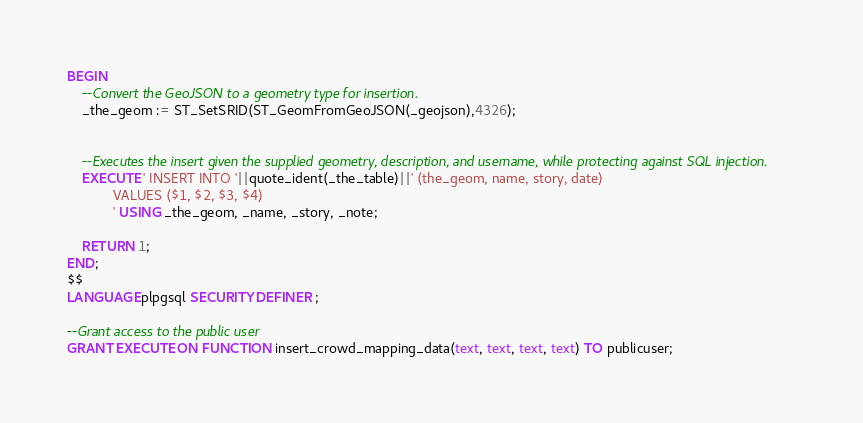Convert code to text. <code><loc_0><loc_0><loc_500><loc_500><_SQL_>BEGIN
    --Convert the GeoJSON to a geometry type for insertion. 
    _the_geom := ST_SetSRID(ST_GeomFromGeoJSON(_geojson),4326); 
	

	--Executes the insert given the supplied geometry, description, and username, while protecting against SQL injection.
    EXECUTE ' INSERT INTO '||quote_ident(_the_table)||' (the_geom, name, story, date)
            VALUES ($1, $2, $3, $4)
            ' USING _the_geom, _name, _story, _note;
            
    RETURN 1;
END;
$$
LANGUAGE plpgsql SECURITY DEFINER ;

--Grant access to the public user
GRANT EXECUTE ON FUNCTION insert_crowd_mapping_data(text, text, text, text) TO publicuser;
</code> 